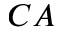<formula> <loc_0><loc_0><loc_500><loc_500>C A</formula> 